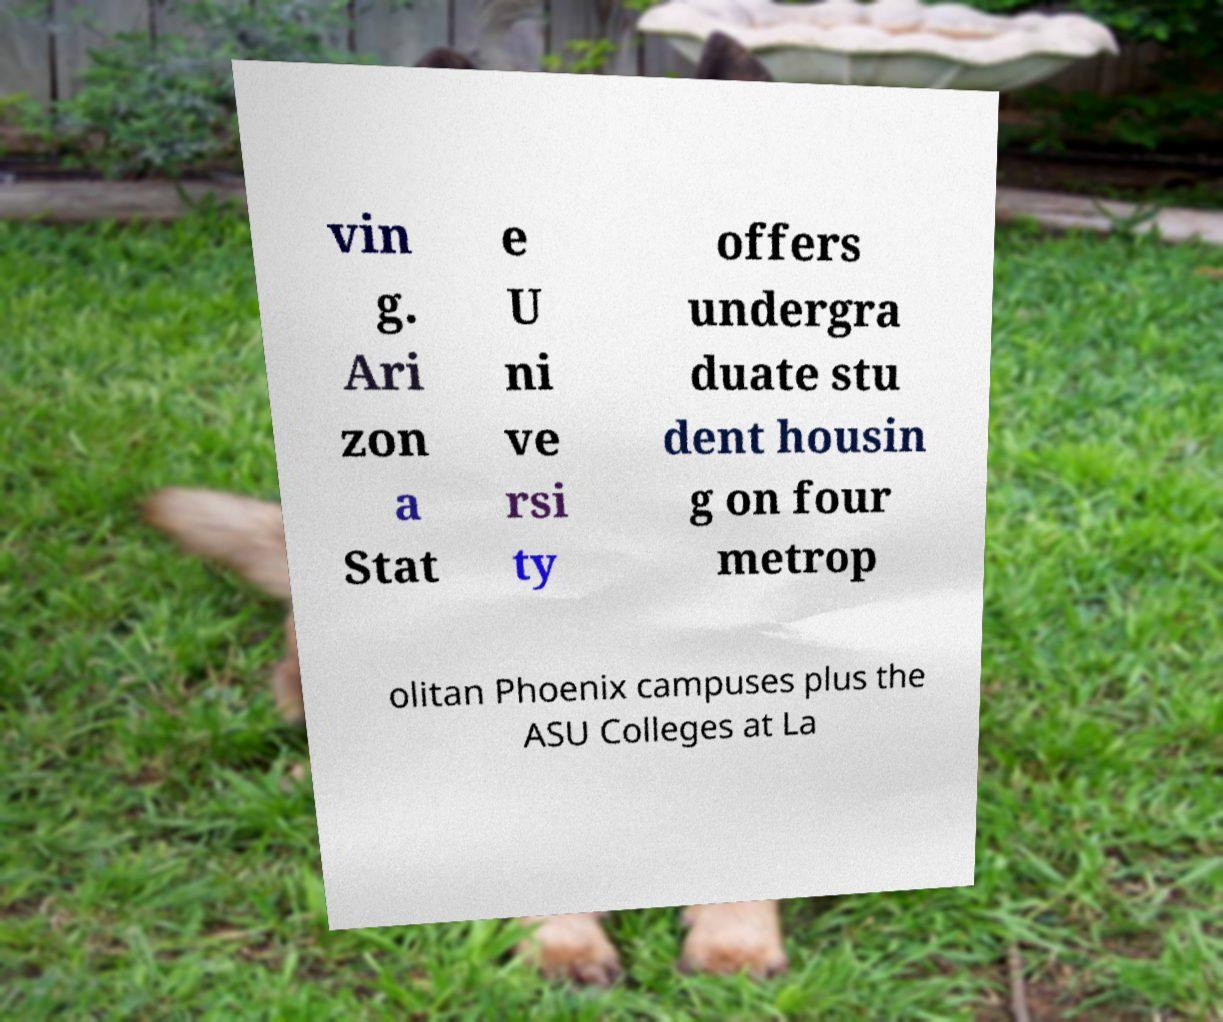Can you accurately transcribe the text from the provided image for me? vin g. Ari zon a Stat e U ni ve rsi ty offers undergra duate stu dent housin g on four metrop olitan Phoenix campuses plus the ASU Colleges at La 